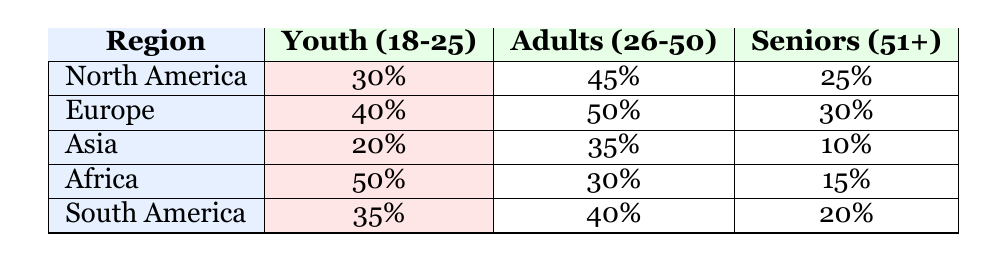What is the participation percentage of Youth (18-25) in North America? The table shows that the participation percentage for Youth (18-25) in North America is 30%.
Answer: 30% Which demographic has the highest participation percentage in Europe? Looking at the Europe row, Adults (26-50) have the highest participation percentage at 50%.
Answer: Adults (26-50) at 50% What is the average participation percentage of Seniors (51+) across all regions? The participation percentages for Seniors (51+) are: North America (25%), Europe (30%), Asia (10%), Africa (15%), and South America (20%). Summing these gives 25 + 30 + 10 + 15 + 20 = 100. There are 5 regions, so the average is 100/5 = 20%.
Answer: 20% Is the participation percentage of Youth (18-25) higher in Africa than in Asia? In Africa, Youth (18-25) participation is 50%, while in Asia it is 20%. Since 50% is greater than 20%, the statement is true.
Answer: Yes Which region has the largest difference in participation between Youth (18-25) and Seniors (51+)? Calculating the differences: North America (30% - 25% = 5%), Europe (40% - 30% = 10%), Asia (20% - 10% = 10%), Africa (50% - 15% = 35%), South America (35% - 20% = 15%). The largest difference is in Africa at 35%.
Answer: Africa at 35% What percentage of Adults (26-50) in Asia participate in interfaith dialogue? According to the table, the participation percentage of Adults (26-50) in Asia is 35%.
Answer: 35% In which region do Seniors (51+) have the lowest participation? The table indicates the participation of Seniors (51+) is 10% in Asia, which is the lowest among all the regions.
Answer: Asia at 10% Are more Adults (26-50) participating in interfaith dialogue in South America compared to Africa? Adults (26-50) participation in South America is 40%, while in Africa it is 30%. Since 40% is greater than 30%, the statement is true.
Answer: Yes 